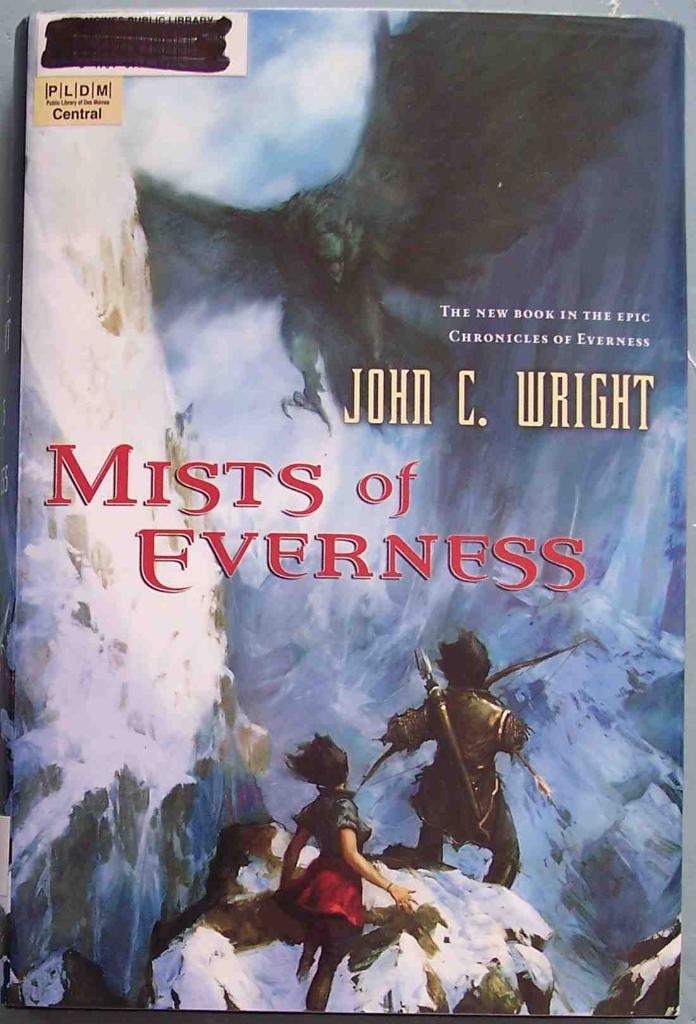<image>
Provide a brief description of the given image. A paperback novel is part of an epic series written by John C. Wright. 